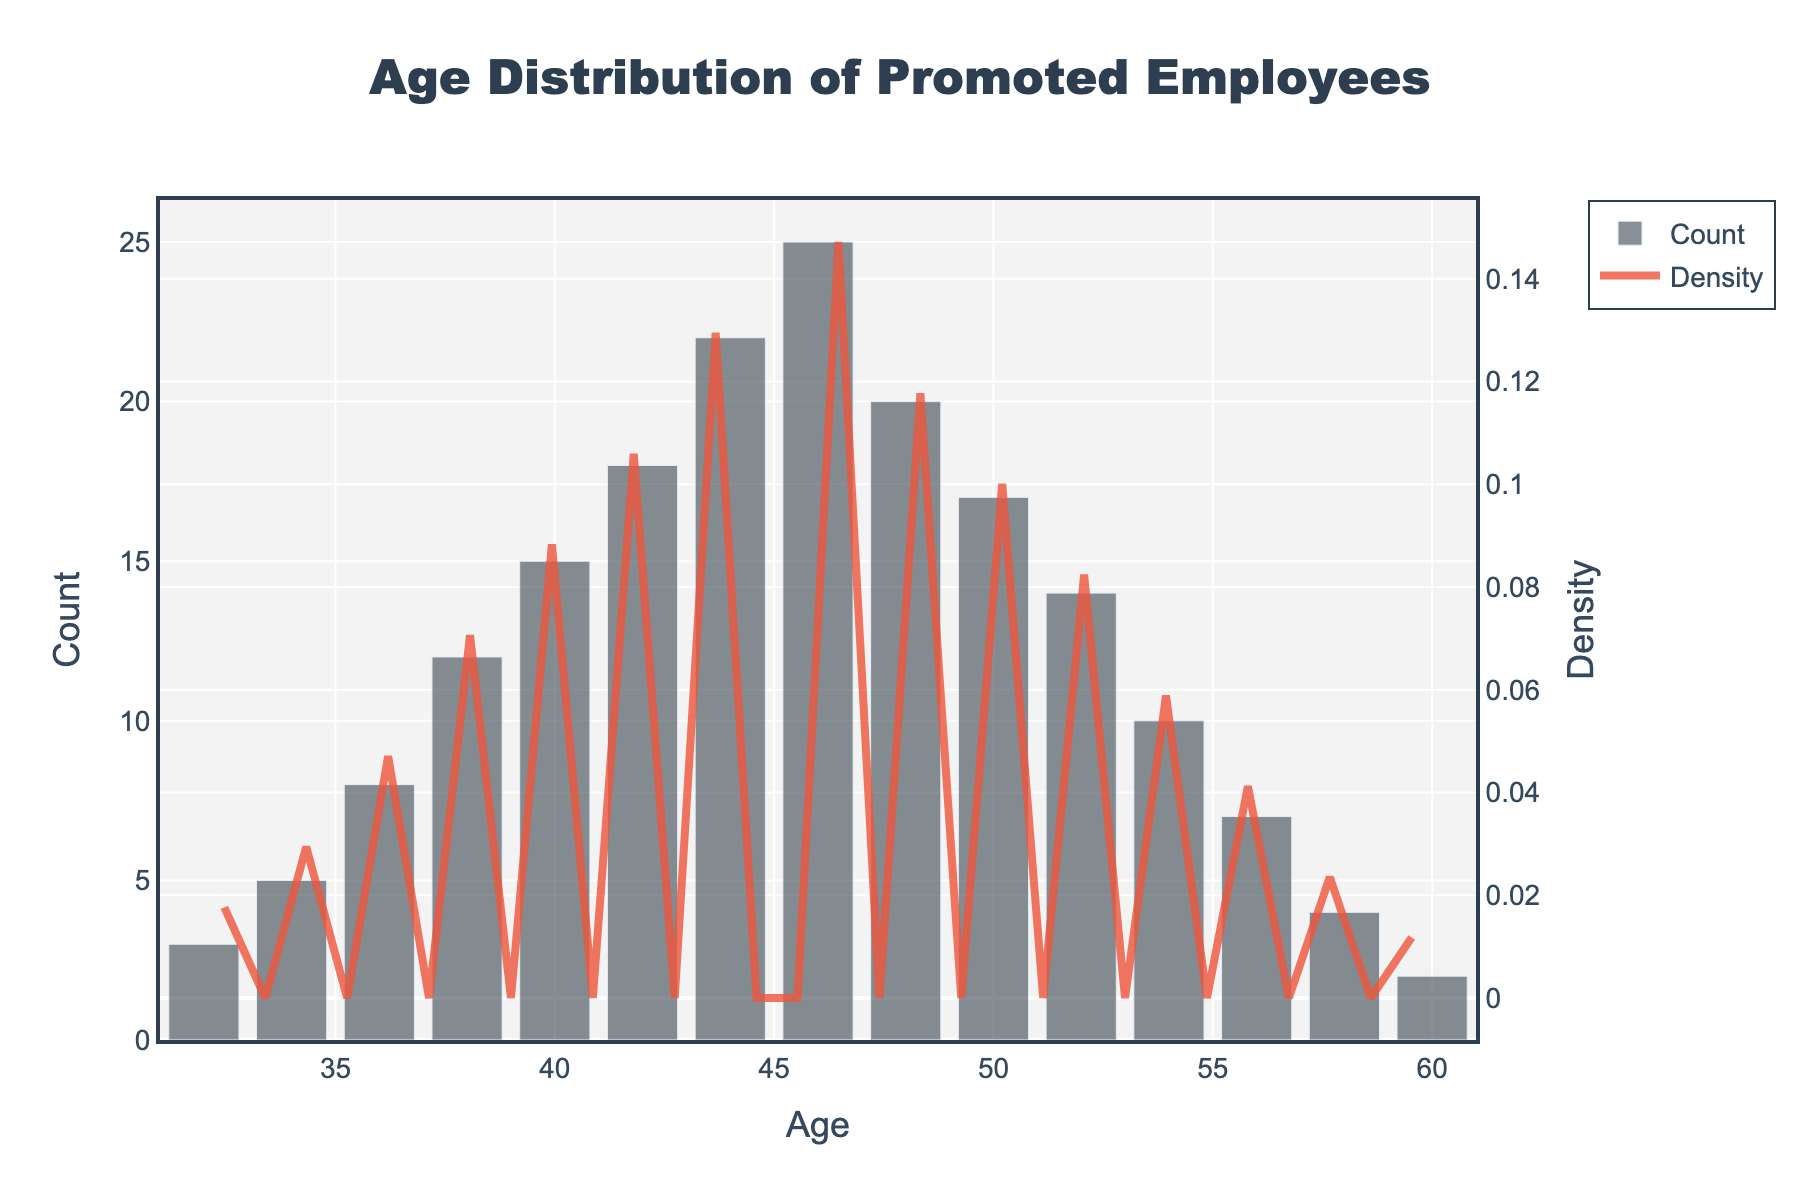What is the title of the figure? The title is usually placed at the top of the chart and is the largest text element. Here, it reads "Age Distribution of Promoted Employees."
Answer: Age Distribution of Promoted Employees What does the x-axis represent? The x-axis is labeled "Age," indicating that it represents the ages of promoted employees. You can see this at the bottom of the chart.
Answer: Age What does the y-axis on the left represent? The y-axis on the left is labeled "Count," showing the number of employees promoted at each age. This is indicated by the label on the left side of the chart.
Answer: Count What color represents the density curve? The density curve is represented by a line that is colored in a distinct way. Looking at the chart, the density curve is a solid line in a reddish (orange) color.
Answer: Reddish (orange) At which age is the count of promoted employees the highest? To find the age with the highest count, look for the tallest bar on the histogram. The tallest bar appears at age 46.
Answer: 46 How many employees were promoted at the age of 40? To find this value, look for the height of the bar at age 40. The bar reaches up to a count of 15.
Answer: 15 What is the general trend observed in the density curve? The density curve trends can be observed by following its shape from left to right. It starts low, peaks towards the ages of 44-46, and then gradually decreases.
Answer: Peaks around 44-46 and then decreases Which age group has the lowest count in the histogram? To find this, look for the shortest bar. The bar at age 60 is the shortest, indicating the lowest count.
Answer: 60 Compare the count of promoted employees between the ages of 32 and 52? Fore each age, looking at the heights of bars, there are 3 employees at 32 and 14 employees at 52. Therefore, 52 has more promoted employees.
Answer: Age 52 has more promoted employees What is the combined count of promoted employees for ages 32, 34, and 36? Add the counts: 3 (age 32) + 5 (age 34) + 8 (age 36) = 16
Answer: 16 